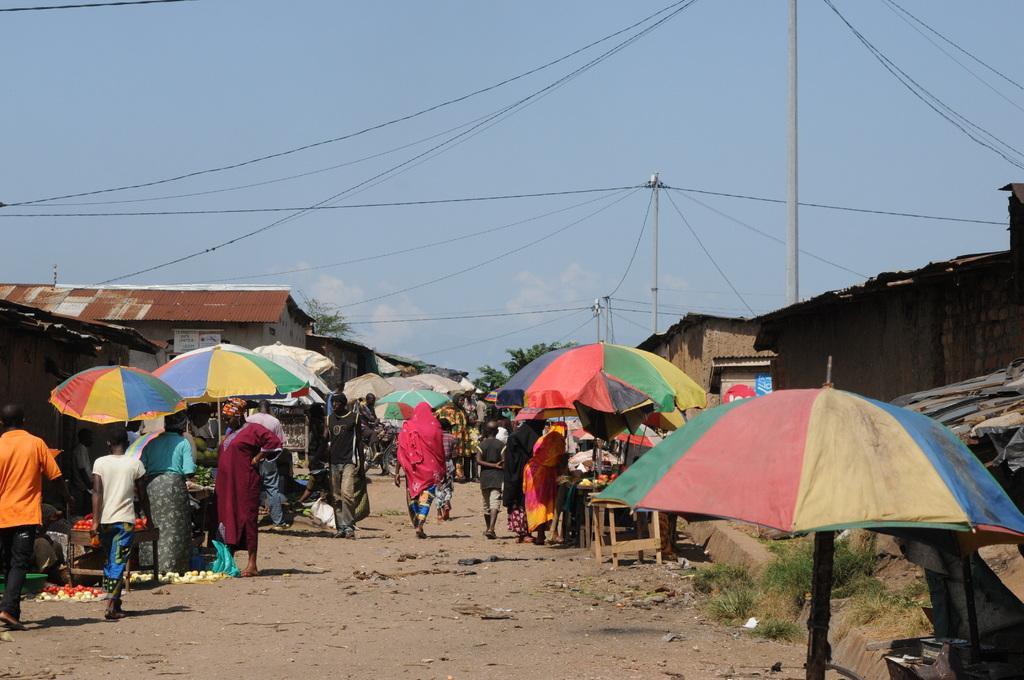Could you give a brief overview of what you see in this image? In this image I can see group of people, some are standing and some are walking. I can also see few multi colored umbrellas, background I can see few sheds and few electric poles and I can see trees in green color and the sky is in blue and white color. 